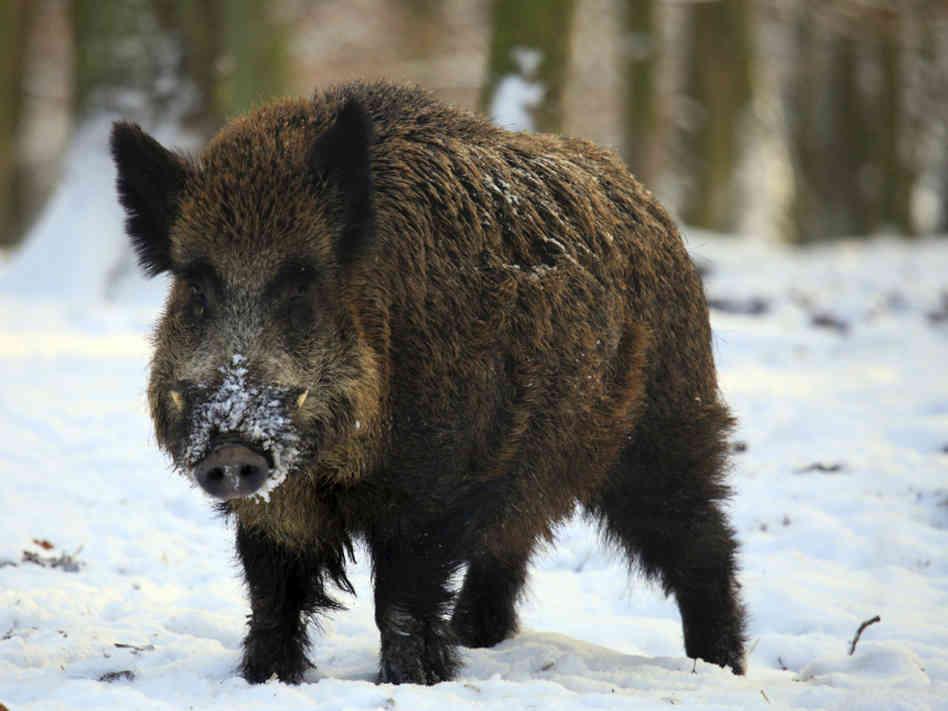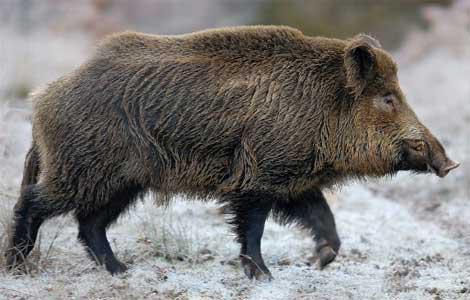The first image is the image on the left, the second image is the image on the right. Evaluate the accuracy of this statement regarding the images: "The one boar in the left image is facing more toward the camera than the boar in the right image.". Is it true? Answer yes or no. Yes. 